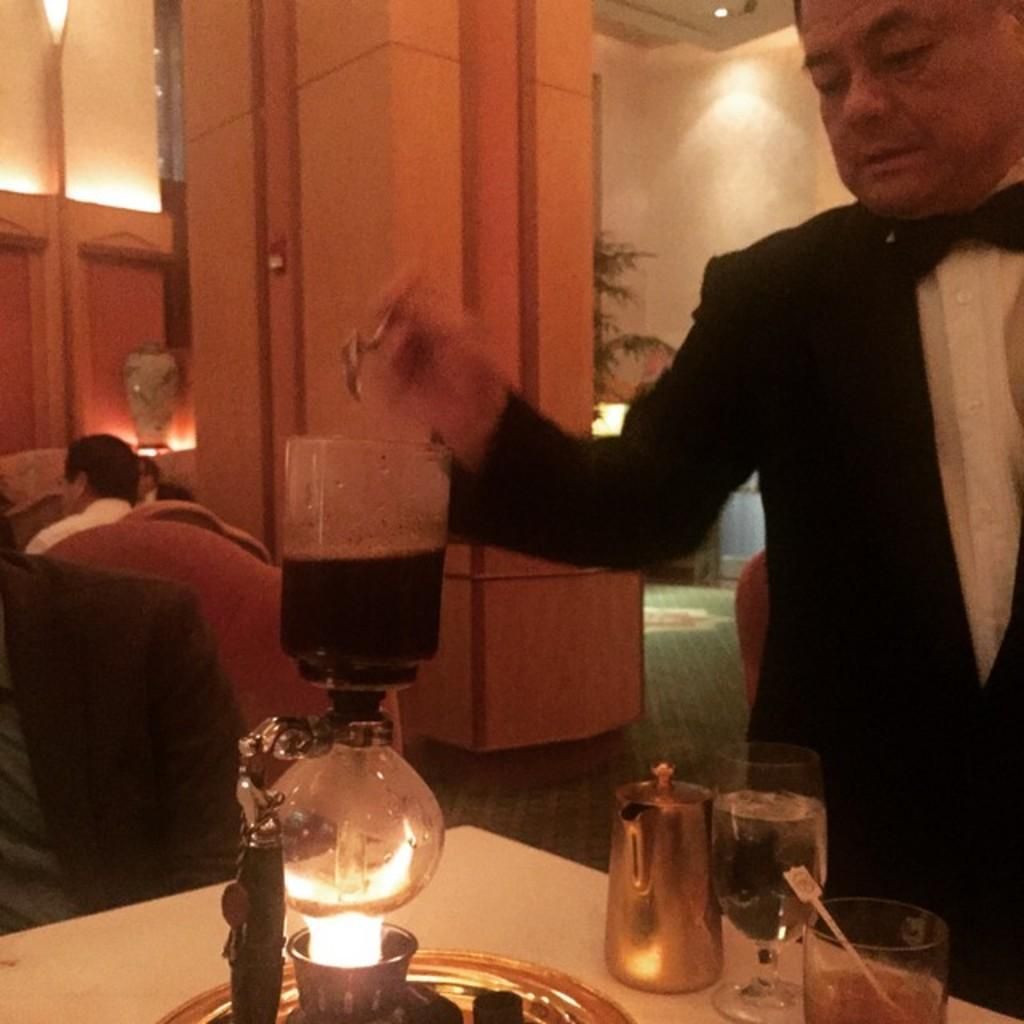What is the main subject of the image? There is a person in the image. What is the person wearing? The person is wearing a black color suit. Is the woman in the image celebrating her birthday? There is no indication in the image that the person is a woman, nor is there any information about a birthday celebration. 